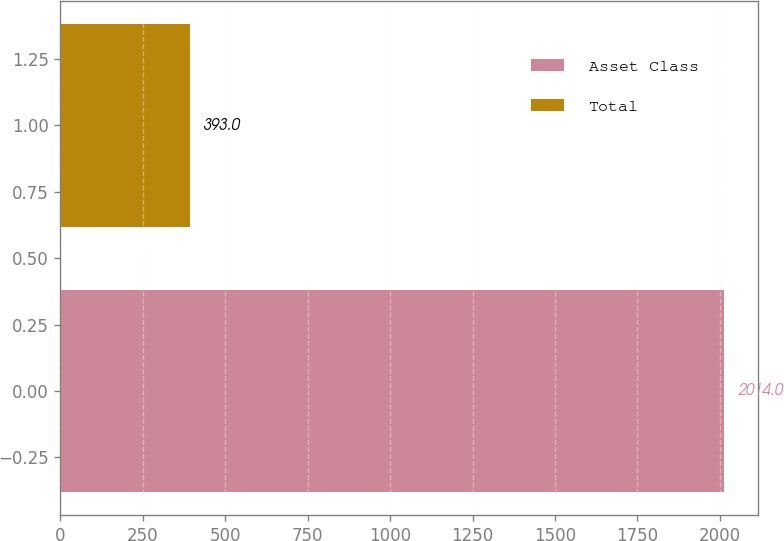Convert chart to OTSL. <chart><loc_0><loc_0><loc_500><loc_500><bar_chart><fcel>Asset Class<fcel>Total<nl><fcel>2014<fcel>393<nl></chart> 